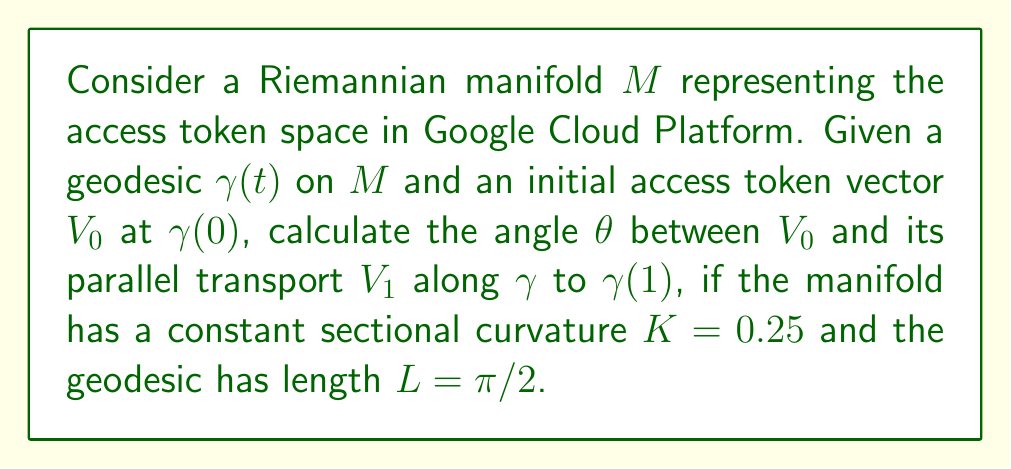Provide a solution to this math problem. To solve this problem, we'll follow these steps:

1) In a Riemannian manifold with constant sectional curvature $K$, the angle $\theta$ between a vector and its parallel transport along a geodesic of length $L$ is given by the formula:

   $$\theta = L \cdot \sqrt{K}$$

2) We are given:
   - Sectional curvature $K = 0.25$
   - Geodesic length $L = \pi/2$

3) Let's substitute these values into the formula:

   $$\theta = (\pi/2) \cdot \sqrt{0.25}$$

4) Simplify $\sqrt{0.25}$:
   
   $$\theta = (\pi/2) \cdot 0.5$$

5) Calculate the final result:

   $$\theta = \pi/4$$

6) Convert to degrees:

   $$\theta = 45°$$

This angle represents the rotation of the access token vector after parallel transport, which could be interpreted as a measure of the change in the token's permissions or scope as it's transferred across different parts of the Google Cloud Platform infrastructure.
Answer: $45°$ or $\pi/4$ radians 